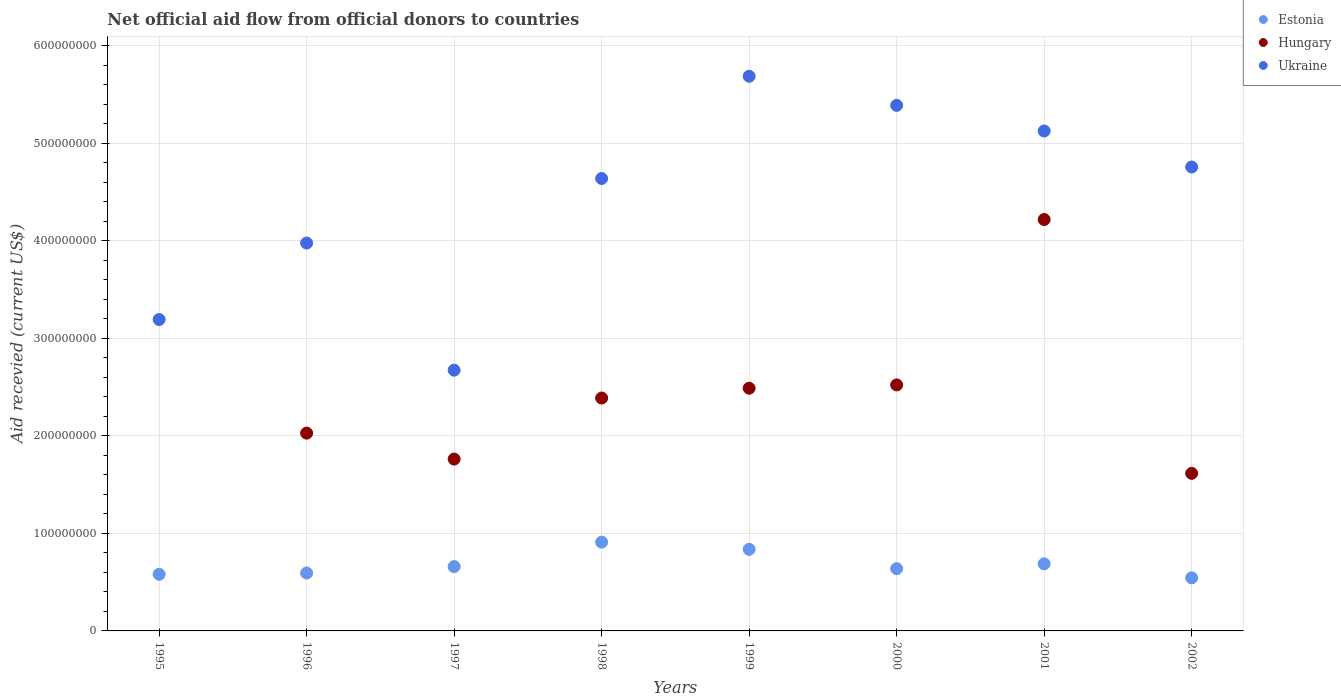How many different coloured dotlines are there?
Your response must be concise. 3. Is the number of dotlines equal to the number of legend labels?
Your answer should be compact. No. What is the total aid received in Hungary in 1997?
Your answer should be very brief. 1.76e+08. Across all years, what is the maximum total aid received in Ukraine?
Your response must be concise. 5.69e+08. In which year was the total aid received in Hungary maximum?
Provide a succinct answer. 2001. What is the total total aid received in Estonia in the graph?
Keep it short and to the point. 5.45e+08. What is the difference between the total aid received in Ukraine in 1996 and that in 1997?
Ensure brevity in your answer.  1.30e+08. What is the difference between the total aid received in Estonia in 2002 and the total aid received in Ukraine in 1997?
Offer a very short reply. -2.13e+08. What is the average total aid received in Hungary per year?
Provide a short and direct response. 2.13e+08. In the year 1996, what is the difference between the total aid received in Hungary and total aid received in Estonia?
Make the answer very short. 1.43e+08. What is the ratio of the total aid received in Hungary in 1998 to that in 1999?
Offer a very short reply. 0.96. Is the difference between the total aid received in Hungary in 2000 and 2001 greater than the difference between the total aid received in Estonia in 2000 and 2001?
Ensure brevity in your answer.  No. What is the difference between the highest and the second highest total aid received in Ukraine?
Provide a short and direct response. 2.98e+07. What is the difference between the highest and the lowest total aid received in Ukraine?
Give a very brief answer. 3.01e+08. In how many years, is the total aid received in Estonia greater than the average total aid received in Estonia taken over all years?
Ensure brevity in your answer.  3. Is the sum of the total aid received in Ukraine in 1997 and 2001 greater than the maximum total aid received in Hungary across all years?
Offer a very short reply. Yes. Is it the case that in every year, the sum of the total aid received in Estonia and total aid received in Hungary  is greater than the total aid received in Ukraine?
Offer a terse response. No. Does the total aid received in Hungary monotonically increase over the years?
Keep it short and to the point. No. How many years are there in the graph?
Your answer should be compact. 8. What is the difference between two consecutive major ticks on the Y-axis?
Provide a succinct answer. 1.00e+08. Does the graph contain grids?
Provide a succinct answer. Yes. Where does the legend appear in the graph?
Make the answer very short. Top right. How many legend labels are there?
Your answer should be very brief. 3. How are the legend labels stacked?
Provide a succinct answer. Vertical. What is the title of the graph?
Keep it short and to the point. Net official aid flow from official donors to countries. What is the label or title of the Y-axis?
Offer a very short reply. Aid recevied (current US$). What is the Aid recevied (current US$) of Estonia in 1995?
Ensure brevity in your answer.  5.80e+07. What is the Aid recevied (current US$) in Hungary in 1995?
Keep it short and to the point. 0. What is the Aid recevied (current US$) of Ukraine in 1995?
Provide a short and direct response. 3.19e+08. What is the Aid recevied (current US$) of Estonia in 1996?
Keep it short and to the point. 5.94e+07. What is the Aid recevied (current US$) in Hungary in 1996?
Offer a terse response. 2.03e+08. What is the Aid recevied (current US$) in Ukraine in 1996?
Ensure brevity in your answer.  3.98e+08. What is the Aid recevied (current US$) in Estonia in 1997?
Provide a succinct answer. 6.59e+07. What is the Aid recevied (current US$) in Hungary in 1997?
Offer a terse response. 1.76e+08. What is the Aid recevied (current US$) in Ukraine in 1997?
Provide a short and direct response. 2.67e+08. What is the Aid recevied (current US$) in Estonia in 1998?
Make the answer very short. 9.10e+07. What is the Aid recevied (current US$) in Hungary in 1998?
Your answer should be very brief. 2.39e+08. What is the Aid recevied (current US$) of Ukraine in 1998?
Ensure brevity in your answer.  4.64e+08. What is the Aid recevied (current US$) of Estonia in 1999?
Provide a short and direct response. 8.36e+07. What is the Aid recevied (current US$) of Hungary in 1999?
Your response must be concise. 2.49e+08. What is the Aid recevied (current US$) of Ukraine in 1999?
Offer a terse response. 5.69e+08. What is the Aid recevied (current US$) of Estonia in 2000?
Make the answer very short. 6.38e+07. What is the Aid recevied (current US$) of Hungary in 2000?
Your response must be concise. 2.52e+08. What is the Aid recevied (current US$) of Ukraine in 2000?
Offer a terse response. 5.39e+08. What is the Aid recevied (current US$) in Estonia in 2001?
Make the answer very short. 6.88e+07. What is the Aid recevied (current US$) in Hungary in 2001?
Offer a terse response. 4.22e+08. What is the Aid recevied (current US$) in Ukraine in 2001?
Provide a succinct answer. 5.12e+08. What is the Aid recevied (current US$) in Estonia in 2002?
Your answer should be compact. 5.44e+07. What is the Aid recevied (current US$) of Hungary in 2002?
Provide a succinct answer. 1.62e+08. What is the Aid recevied (current US$) of Ukraine in 2002?
Offer a very short reply. 4.76e+08. Across all years, what is the maximum Aid recevied (current US$) in Estonia?
Provide a short and direct response. 9.10e+07. Across all years, what is the maximum Aid recevied (current US$) in Hungary?
Provide a short and direct response. 4.22e+08. Across all years, what is the maximum Aid recevied (current US$) of Ukraine?
Provide a succinct answer. 5.69e+08. Across all years, what is the minimum Aid recevied (current US$) of Estonia?
Provide a short and direct response. 5.44e+07. Across all years, what is the minimum Aid recevied (current US$) of Hungary?
Provide a short and direct response. 0. Across all years, what is the minimum Aid recevied (current US$) of Ukraine?
Ensure brevity in your answer.  2.67e+08. What is the total Aid recevied (current US$) of Estonia in the graph?
Your response must be concise. 5.45e+08. What is the total Aid recevied (current US$) of Hungary in the graph?
Offer a terse response. 1.70e+09. What is the total Aid recevied (current US$) in Ukraine in the graph?
Your answer should be very brief. 3.54e+09. What is the difference between the Aid recevied (current US$) of Estonia in 1995 and that in 1996?
Your answer should be very brief. -1.32e+06. What is the difference between the Aid recevied (current US$) in Ukraine in 1995 and that in 1996?
Keep it short and to the point. -7.84e+07. What is the difference between the Aid recevied (current US$) of Estonia in 1995 and that in 1997?
Your answer should be compact. -7.86e+06. What is the difference between the Aid recevied (current US$) in Ukraine in 1995 and that in 1997?
Ensure brevity in your answer.  5.19e+07. What is the difference between the Aid recevied (current US$) in Estonia in 1995 and that in 1998?
Ensure brevity in your answer.  -3.29e+07. What is the difference between the Aid recevied (current US$) of Ukraine in 1995 and that in 1998?
Your answer should be compact. -1.45e+08. What is the difference between the Aid recevied (current US$) in Estonia in 1995 and that in 1999?
Provide a short and direct response. -2.56e+07. What is the difference between the Aid recevied (current US$) of Ukraine in 1995 and that in 1999?
Your response must be concise. -2.49e+08. What is the difference between the Aid recevied (current US$) of Estonia in 1995 and that in 2000?
Your answer should be compact. -5.78e+06. What is the difference between the Aid recevied (current US$) of Ukraine in 1995 and that in 2000?
Provide a succinct answer. -2.20e+08. What is the difference between the Aid recevied (current US$) of Estonia in 1995 and that in 2001?
Ensure brevity in your answer.  -1.07e+07. What is the difference between the Aid recevied (current US$) of Ukraine in 1995 and that in 2001?
Provide a short and direct response. -1.93e+08. What is the difference between the Aid recevied (current US$) in Estonia in 1995 and that in 2002?
Make the answer very short. 3.64e+06. What is the difference between the Aid recevied (current US$) of Ukraine in 1995 and that in 2002?
Provide a succinct answer. -1.56e+08. What is the difference between the Aid recevied (current US$) of Estonia in 1996 and that in 1997?
Provide a succinct answer. -6.54e+06. What is the difference between the Aid recevied (current US$) of Hungary in 1996 and that in 1997?
Ensure brevity in your answer.  2.66e+07. What is the difference between the Aid recevied (current US$) in Ukraine in 1996 and that in 1997?
Your answer should be very brief. 1.30e+08. What is the difference between the Aid recevied (current US$) of Estonia in 1996 and that in 1998?
Make the answer very short. -3.16e+07. What is the difference between the Aid recevied (current US$) of Hungary in 1996 and that in 1998?
Make the answer very short. -3.60e+07. What is the difference between the Aid recevied (current US$) of Ukraine in 1996 and that in 1998?
Your answer should be very brief. -6.61e+07. What is the difference between the Aid recevied (current US$) in Estonia in 1996 and that in 1999?
Offer a terse response. -2.42e+07. What is the difference between the Aid recevied (current US$) in Hungary in 1996 and that in 1999?
Offer a terse response. -4.60e+07. What is the difference between the Aid recevied (current US$) of Ukraine in 1996 and that in 1999?
Give a very brief answer. -1.71e+08. What is the difference between the Aid recevied (current US$) in Estonia in 1996 and that in 2000?
Provide a short and direct response. -4.46e+06. What is the difference between the Aid recevied (current US$) in Hungary in 1996 and that in 2000?
Ensure brevity in your answer.  -4.94e+07. What is the difference between the Aid recevied (current US$) in Ukraine in 1996 and that in 2000?
Offer a terse response. -1.41e+08. What is the difference between the Aid recevied (current US$) of Estonia in 1996 and that in 2001?
Keep it short and to the point. -9.41e+06. What is the difference between the Aid recevied (current US$) in Hungary in 1996 and that in 2001?
Offer a terse response. -2.19e+08. What is the difference between the Aid recevied (current US$) in Ukraine in 1996 and that in 2001?
Give a very brief answer. -1.15e+08. What is the difference between the Aid recevied (current US$) in Estonia in 1996 and that in 2002?
Make the answer very short. 4.96e+06. What is the difference between the Aid recevied (current US$) in Hungary in 1996 and that in 2002?
Keep it short and to the point. 4.12e+07. What is the difference between the Aid recevied (current US$) in Ukraine in 1996 and that in 2002?
Keep it short and to the point. -7.79e+07. What is the difference between the Aid recevied (current US$) in Estonia in 1997 and that in 1998?
Make the answer very short. -2.51e+07. What is the difference between the Aid recevied (current US$) of Hungary in 1997 and that in 1998?
Your answer should be compact. -6.26e+07. What is the difference between the Aid recevied (current US$) in Ukraine in 1997 and that in 1998?
Ensure brevity in your answer.  -1.96e+08. What is the difference between the Aid recevied (current US$) of Estonia in 1997 and that in 1999?
Give a very brief answer. -1.77e+07. What is the difference between the Aid recevied (current US$) of Hungary in 1997 and that in 1999?
Your answer should be compact. -7.26e+07. What is the difference between the Aid recevied (current US$) of Ukraine in 1997 and that in 1999?
Provide a succinct answer. -3.01e+08. What is the difference between the Aid recevied (current US$) in Estonia in 1997 and that in 2000?
Offer a terse response. 2.08e+06. What is the difference between the Aid recevied (current US$) in Hungary in 1997 and that in 2000?
Your response must be concise. -7.60e+07. What is the difference between the Aid recevied (current US$) of Ukraine in 1997 and that in 2000?
Ensure brevity in your answer.  -2.71e+08. What is the difference between the Aid recevied (current US$) in Estonia in 1997 and that in 2001?
Provide a short and direct response. -2.87e+06. What is the difference between the Aid recevied (current US$) of Hungary in 1997 and that in 2001?
Your answer should be compact. -2.46e+08. What is the difference between the Aid recevied (current US$) in Ukraine in 1997 and that in 2001?
Your response must be concise. -2.45e+08. What is the difference between the Aid recevied (current US$) of Estonia in 1997 and that in 2002?
Make the answer very short. 1.15e+07. What is the difference between the Aid recevied (current US$) of Hungary in 1997 and that in 2002?
Your answer should be very brief. 1.46e+07. What is the difference between the Aid recevied (current US$) of Ukraine in 1997 and that in 2002?
Keep it short and to the point. -2.08e+08. What is the difference between the Aid recevied (current US$) in Estonia in 1998 and that in 1999?
Your answer should be very brief. 7.37e+06. What is the difference between the Aid recevied (current US$) in Hungary in 1998 and that in 1999?
Your answer should be very brief. -1.00e+07. What is the difference between the Aid recevied (current US$) of Ukraine in 1998 and that in 1999?
Give a very brief answer. -1.05e+08. What is the difference between the Aid recevied (current US$) in Estonia in 1998 and that in 2000?
Give a very brief answer. 2.72e+07. What is the difference between the Aid recevied (current US$) of Hungary in 1998 and that in 2000?
Offer a terse response. -1.34e+07. What is the difference between the Aid recevied (current US$) in Ukraine in 1998 and that in 2000?
Make the answer very short. -7.50e+07. What is the difference between the Aid recevied (current US$) of Estonia in 1998 and that in 2001?
Your answer should be compact. 2.22e+07. What is the difference between the Aid recevied (current US$) of Hungary in 1998 and that in 2001?
Your answer should be compact. -1.83e+08. What is the difference between the Aid recevied (current US$) of Ukraine in 1998 and that in 2001?
Offer a very short reply. -4.87e+07. What is the difference between the Aid recevied (current US$) of Estonia in 1998 and that in 2002?
Your response must be concise. 3.66e+07. What is the difference between the Aid recevied (current US$) of Hungary in 1998 and that in 2002?
Offer a very short reply. 7.72e+07. What is the difference between the Aid recevied (current US$) of Ukraine in 1998 and that in 2002?
Offer a terse response. -1.18e+07. What is the difference between the Aid recevied (current US$) of Estonia in 1999 and that in 2000?
Give a very brief answer. 1.98e+07. What is the difference between the Aid recevied (current US$) of Hungary in 1999 and that in 2000?
Make the answer very short. -3.39e+06. What is the difference between the Aid recevied (current US$) in Ukraine in 1999 and that in 2000?
Ensure brevity in your answer.  2.98e+07. What is the difference between the Aid recevied (current US$) in Estonia in 1999 and that in 2001?
Your response must be concise. 1.48e+07. What is the difference between the Aid recevied (current US$) of Hungary in 1999 and that in 2001?
Provide a short and direct response. -1.73e+08. What is the difference between the Aid recevied (current US$) of Ukraine in 1999 and that in 2001?
Ensure brevity in your answer.  5.61e+07. What is the difference between the Aid recevied (current US$) in Estonia in 1999 and that in 2002?
Offer a terse response. 2.92e+07. What is the difference between the Aid recevied (current US$) in Hungary in 1999 and that in 2002?
Provide a succinct answer. 8.73e+07. What is the difference between the Aid recevied (current US$) in Ukraine in 1999 and that in 2002?
Make the answer very short. 9.30e+07. What is the difference between the Aid recevied (current US$) in Estonia in 2000 and that in 2001?
Ensure brevity in your answer.  -4.95e+06. What is the difference between the Aid recevied (current US$) of Hungary in 2000 and that in 2001?
Your answer should be compact. -1.70e+08. What is the difference between the Aid recevied (current US$) in Ukraine in 2000 and that in 2001?
Provide a short and direct response. 2.62e+07. What is the difference between the Aid recevied (current US$) of Estonia in 2000 and that in 2002?
Offer a very short reply. 9.42e+06. What is the difference between the Aid recevied (current US$) in Hungary in 2000 and that in 2002?
Provide a short and direct response. 9.06e+07. What is the difference between the Aid recevied (current US$) in Ukraine in 2000 and that in 2002?
Provide a succinct answer. 6.32e+07. What is the difference between the Aid recevied (current US$) of Estonia in 2001 and that in 2002?
Give a very brief answer. 1.44e+07. What is the difference between the Aid recevied (current US$) in Hungary in 2001 and that in 2002?
Provide a succinct answer. 2.60e+08. What is the difference between the Aid recevied (current US$) of Ukraine in 2001 and that in 2002?
Offer a very short reply. 3.69e+07. What is the difference between the Aid recevied (current US$) of Estonia in 1995 and the Aid recevied (current US$) of Hungary in 1996?
Ensure brevity in your answer.  -1.45e+08. What is the difference between the Aid recevied (current US$) in Estonia in 1995 and the Aid recevied (current US$) in Ukraine in 1996?
Make the answer very short. -3.40e+08. What is the difference between the Aid recevied (current US$) of Estonia in 1995 and the Aid recevied (current US$) of Hungary in 1997?
Ensure brevity in your answer.  -1.18e+08. What is the difference between the Aid recevied (current US$) of Estonia in 1995 and the Aid recevied (current US$) of Ukraine in 1997?
Keep it short and to the point. -2.09e+08. What is the difference between the Aid recevied (current US$) of Estonia in 1995 and the Aid recevied (current US$) of Hungary in 1998?
Your answer should be compact. -1.81e+08. What is the difference between the Aid recevied (current US$) in Estonia in 1995 and the Aid recevied (current US$) in Ukraine in 1998?
Provide a short and direct response. -4.06e+08. What is the difference between the Aid recevied (current US$) of Estonia in 1995 and the Aid recevied (current US$) of Hungary in 1999?
Offer a very short reply. -1.91e+08. What is the difference between the Aid recevied (current US$) in Estonia in 1995 and the Aid recevied (current US$) in Ukraine in 1999?
Keep it short and to the point. -5.11e+08. What is the difference between the Aid recevied (current US$) of Estonia in 1995 and the Aid recevied (current US$) of Hungary in 2000?
Provide a succinct answer. -1.94e+08. What is the difference between the Aid recevied (current US$) in Estonia in 1995 and the Aid recevied (current US$) in Ukraine in 2000?
Ensure brevity in your answer.  -4.81e+08. What is the difference between the Aid recevied (current US$) of Estonia in 1995 and the Aid recevied (current US$) of Hungary in 2001?
Provide a short and direct response. -3.64e+08. What is the difference between the Aid recevied (current US$) of Estonia in 1995 and the Aid recevied (current US$) of Ukraine in 2001?
Offer a very short reply. -4.54e+08. What is the difference between the Aid recevied (current US$) in Estonia in 1995 and the Aid recevied (current US$) in Hungary in 2002?
Offer a very short reply. -1.03e+08. What is the difference between the Aid recevied (current US$) of Estonia in 1995 and the Aid recevied (current US$) of Ukraine in 2002?
Your answer should be very brief. -4.18e+08. What is the difference between the Aid recevied (current US$) in Estonia in 1996 and the Aid recevied (current US$) in Hungary in 1997?
Provide a succinct answer. -1.17e+08. What is the difference between the Aid recevied (current US$) of Estonia in 1996 and the Aid recevied (current US$) of Ukraine in 1997?
Offer a very short reply. -2.08e+08. What is the difference between the Aid recevied (current US$) of Hungary in 1996 and the Aid recevied (current US$) of Ukraine in 1997?
Your answer should be compact. -6.45e+07. What is the difference between the Aid recevied (current US$) of Estonia in 1996 and the Aid recevied (current US$) of Hungary in 1998?
Your answer should be very brief. -1.79e+08. What is the difference between the Aid recevied (current US$) in Estonia in 1996 and the Aid recevied (current US$) in Ukraine in 1998?
Provide a succinct answer. -4.04e+08. What is the difference between the Aid recevied (current US$) of Hungary in 1996 and the Aid recevied (current US$) of Ukraine in 1998?
Your answer should be very brief. -2.61e+08. What is the difference between the Aid recevied (current US$) of Estonia in 1996 and the Aid recevied (current US$) of Hungary in 1999?
Provide a short and direct response. -1.89e+08. What is the difference between the Aid recevied (current US$) of Estonia in 1996 and the Aid recevied (current US$) of Ukraine in 1999?
Offer a very short reply. -5.09e+08. What is the difference between the Aid recevied (current US$) of Hungary in 1996 and the Aid recevied (current US$) of Ukraine in 1999?
Keep it short and to the point. -3.66e+08. What is the difference between the Aid recevied (current US$) of Estonia in 1996 and the Aid recevied (current US$) of Hungary in 2000?
Offer a very short reply. -1.93e+08. What is the difference between the Aid recevied (current US$) of Estonia in 1996 and the Aid recevied (current US$) of Ukraine in 2000?
Your response must be concise. -4.79e+08. What is the difference between the Aid recevied (current US$) of Hungary in 1996 and the Aid recevied (current US$) of Ukraine in 2000?
Make the answer very short. -3.36e+08. What is the difference between the Aid recevied (current US$) of Estonia in 1996 and the Aid recevied (current US$) of Hungary in 2001?
Your response must be concise. -3.62e+08. What is the difference between the Aid recevied (current US$) in Estonia in 1996 and the Aid recevied (current US$) in Ukraine in 2001?
Provide a succinct answer. -4.53e+08. What is the difference between the Aid recevied (current US$) in Hungary in 1996 and the Aid recevied (current US$) in Ukraine in 2001?
Make the answer very short. -3.10e+08. What is the difference between the Aid recevied (current US$) of Estonia in 1996 and the Aid recevied (current US$) of Hungary in 2002?
Offer a very short reply. -1.02e+08. What is the difference between the Aid recevied (current US$) in Estonia in 1996 and the Aid recevied (current US$) in Ukraine in 2002?
Give a very brief answer. -4.16e+08. What is the difference between the Aid recevied (current US$) of Hungary in 1996 and the Aid recevied (current US$) of Ukraine in 2002?
Ensure brevity in your answer.  -2.73e+08. What is the difference between the Aid recevied (current US$) in Estonia in 1997 and the Aid recevied (current US$) in Hungary in 1998?
Your response must be concise. -1.73e+08. What is the difference between the Aid recevied (current US$) of Estonia in 1997 and the Aid recevied (current US$) of Ukraine in 1998?
Your response must be concise. -3.98e+08. What is the difference between the Aid recevied (current US$) of Hungary in 1997 and the Aid recevied (current US$) of Ukraine in 1998?
Offer a terse response. -2.88e+08. What is the difference between the Aid recevied (current US$) in Estonia in 1997 and the Aid recevied (current US$) in Hungary in 1999?
Provide a succinct answer. -1.83e+08. What is the difference between the Aid recevied (current US$) in Estonia in 1997 and the Aid recevied (current US$) in Ukraine in 1999?
Offer a terse response. -5.03e+08. What is the difference between the Aid recevied (current US$) in Hungary in 1997 and the Aid recevied (current US$) in Ukraine in 1999?
Provide a succinct answer. -3.92e+08. What is the difference between the Aid recevied (current US$) of Estonia in 1997 and the Aid recevied (current US$) of Hungary in 2000?
Make the answer very short. -1.86e+08. What is the difference between the Aid recevied (current US$) of Estonia in 1997 and the Aid recevied (current US$) of Ukraine in 2000?
Your answer should be compact. -4.73e+08. What is the difference between the Aid recevied (current US$) of Hungary in 1997 and the Aid recevied (current US$) of Ukraine in 2000?
Keep it short and to the point. -3.63e+08. What is the difference between the Aid recevied (current US$) in Estonia in 1997 and the Aid recevied (current US$) in Hungary in 2001?
Your answer should be very brief. -3.56e+08. What is the difference between the Aid recevied (current US$) of Estonia in 1997 and the Aid recevied (current US$) of Ukraine in 2001?
Keep it short and to the point. -4.47e+08. What is the difference between the Aid recevied (current US$) of Hungary in 1997 and the Aid recevied (current US$) of Ukraine in 2001?
Provide a short and direct response. -3.36e+08. What is the difference between the Aid recevied (current US$) in Estonia in 1997 and the Aid recevied (current US$) in Hungary in 2002?
Give a very brief answer. -9.56e+07. What is the difference between the Aid recevied (current US$) in Estonia in 1997 and the Aid recevied (current US$) in Ukraine in 2002?
Your answer should be very brief. -4.10e+08. What is the difference between the Aid recevied (current US$) of Hungary in 1997 and the Aid recevied (current US$) of Ukraine in 2002?
Ensure brevity in your answer.  -2.99e+08. What is the difference between the Aid recevied (current US$) of Estonia in 1998 and the Aid recevied (current US$) of Hungary in 1999?
Your response must be concise. -1.58e+08. What is the difference between the Aid recevied (current US$) of Estonia in 1998 and the Aid recevied (current US$) of Ukraine in 1999?
Your answer should be very brief. -4.78e+08. What is the difference between the Aid recevied (current US$) of Hungary in 1998 and the Aid recevied (current US$) of Ukraine in 1999?
Offer a terse response. -3.30e+08. What is the difference between the Aid recevied (current US$) in Estonia in 1998 and the Aid recevied (current US$) in Hungary in 2000?
Your response must be concise. -1.61e+08. What is the difference between the Aid recevied (current US$) in Estonia in 1998 and the Aid recevied (current US$) in Ukraine in 2000?
Ensure brevity in your answer.  -4.48e+08. What is the difference between the Aid recevied (current US$) of Hungary in 1998 and the Aid recevied (current US$) of Ukraine in 2000?
Your answer should be compact. -3.00e+08. What is the difference between the Aid recevied (current US$) in Estonia in 1998 and the Aid recevied (current US$) in Hungary in 2001?
Your answer should be very brief. -3.31e+08. What is the difference between the Aid recevied (current US$) in Estonia in 1998 and the Aid recevied (current US$) in Ukraine in 2001?
Make the answer very short. -4.21e+08. What is the difference between the Aid recevied (current US$) in Hungary in 1998 and the Aid recevied (current US$) in Ukraine in 2001?
Make the answer very short. -2.74e+08. What is the difference between the Aid recevied (current US$) in Estonia in 1998 and the Aid recevied (current US$) in Hungary in 2002?
Offer a terse response. -7.05e+07. What is the difference between the Aid recevied (current US$) of Estonia in 1998 and the Aid recevied (current US$) of Ukraine in 2002?
Provide a short and direct response. -3.85e+08. What is the difference between the Aid recevied (current US$) of Hungary in 1998 and the Aid recevied (current US$) of Ukraine in 2002?
Make the answer very short. -2.37e+08. What is the difference between the Aid recevied (current US$) in Estonia in 1999 and the Aid recevied (current US$) in Hungary in 2000?
Provide a short and direct response. -1.69e+08. What is the difference between the Aid recevied (current US$) of Estonia in 1999 and the Aid recevied (current US$) of Ukraine in 2000?
Offer a terse response. -4.55e+08. What is the difference between the Aid recevied (current US$) of Hungary in 1999 and the Aid recevied (current US$) of Ukraine in 2000?
Keep it short and to the point. -2.90e+08. What is the difference between the Aid recevied (current US$) of Estonia in 1999 and the Aid recevied (current US$) of Hungary in 2001?
Your answer should be compact. -3.38e+08. What is the difference between the Aid recevied (current US$) of Estonia in 1999 and the Aid recevied (current US$) of Ukraine in 2001?
Make the answer very short. -4.29e+08. What is the difference between the Aid recevied (current US$) in Hungary in 1999 and the Aid recevied (current US$) in Ukraine in 2001?
Your answer should be very brief. -2.64e+08. What is the difference between the Aid recevied (current US$) of Estonia in 1999 and the Aid recevied (current US$) of Hungary in 2002?
Provide a succinct answer. -7.79e+07. What is the difference between the Aid recevied (current US$) in Estonia in 1999 and the Aid recevied (current US$) in Ukraine in 2002?
Keep it short and to the point. -3.92e+08. What is the difference between the Aid recevied (current US$) in Hungary in 1999 and the Aid recevied (current US$) in Ukraine in 2002?
Ensure brevity in your answer.  -2.27e+08. What is the difference between the Aid recevied (current US$) of Estonia in 2000 and the Aid recevied (current US$) of Hungary in 2001?
Keep it short and to the point. -3.58e+08. What is the difference between the Aid recevied (current US$) in Estonia in 2000 and the Aid recevied (current US$) in Ukraine in 2001?
Your response must be concise. -4.49e+08. What is the difference between the Aid recevied (current US$) of Hungary in 2000 and the Aid recevied (current US$) of Ukraine in 2001?
Make the answer very short. -2.60e+08. What is the difference between the Aid recevied (current US$) of Estonia in 2000 and the Aid recevied (current US$) of Hungary in 2002?
Offer a terse response. -9.77e+07. What is the difference between the Aid recevied (current US$) in Estonia in 2000 and the Aid recevied (current US$) in Ukraine in 2002?
Ensure brevity in your answer.  -4.12e+08. What is the difference between the Aid recevied (current US$) in Hungary in 2000 and the Aid recevied (current US$) in Ukraine in 2002?
Your answer should be compact. -2.23e+08. What is the difference between the Aid recevied (current US$) in Estonia in 2001 and the Aid recevied (current US$) in Hungary in 2002?
Your answer should be very brief. -9.27e+07. What is the difference between the Aid recevied (current US$) in Estonia in 2001 and the Aid recevied (current US$) in Ukraine in 2002?
Provide a short and direct response. -4.07e+08. What is the difference between the Aid recevied (current US$) of Hungary in 2001 and the Aid recevied (current US$) of Ukraine in 2002?
Your answer should be very brief. -5.39e+07. What is the average Aid recevied (current US$) in Estonia per year?
Your answer should be compact. 6.81e+07. What is the average Aid recevied (current US$) of Hungary per year?
Offer a very short reply. 2.13e+08. What is the average Aid recevied (current US$) of Ukraine per year?
Make the answer very short. 4.43e+08. In the year 1995, what is the difference between the Aid recevied (current US$) in Estonia and Aid recevied (current US$) in Ukraine?
Give a very brief answer. -2.61e+08. In the year 1996, what is the difference between the Aid recevied (current US$) of Estonia and Aid recevied (current US$) of Hungary?
Your response must be concise. -1.43e+08. In the year 1996, what is the difference between the Aid recevied (current US$) in Estonia and Aid recevied (current US$) in Ukraine?
Offer a terse response. -3.38e+08. In the year 1996, what is the difference between the Aid recevied (current US$) of Hungary and Aid recevied (current US$) of Ukraine?
Make the answer very short. -1.95e+08. In the year 1997, what is the difference between the Aid recevied (current US$) in Estonia and Aid recevied (current US$) in Hungary?
Give a very brief answer. -1.10e+08. In the year 1997, what is the difference between the Aid recevied (current US$) of Estonia and Aid recevied (current US$) of Ukraine?
Offer a very short reply. -2.01e+08. In the year 1997, what is the difference between the Aid recevied (current US$) of Hungary and Aid recevied (current US$) of Ukraine?
Offer a very short reply. -9.11e+07. In the year 1998, what is the difference between the Aid recevied (current US$) in Estonia and Aid recevied (current US$) in Hungary?
Provide a short and direct response. -1.48e+08. In the year 1998, what is the difference between the Aid recevied (current US$) in Estonia and Aid recevied (current US$) in Ukraine?
Offer a very short reply. -3.73e+08. In the year 1998, what is the difference between the Aid recevied (current US$) of Hungary and Aid recevied (current US$) of Ukraine?
Offer a very short reply. -2.25e+08. In the year 1999, what is the difference between the Aid recevied (current US$) in Estonia and Aid recevied (current US$) in Hungary?
Make the answer very short. -1.65e+08. In the year 1999, what is the difference between the Aid recevied (current US$) of Estonia and Aid recevied (current US$) of Ukraine?
Provide a succinct answer. -4.85e+08. In the year 1999, what is the difference between the Aid recevied (current US$) in Hungary and Aid recevied (current US$) in Ukraine?
Provide a short and direct response. -3.20e+08. In the year 2000, what is the difference between the Aid recevied (current US$) of Estonia and Aid recevied (current US$) of Hungary?
Provide a succinct answer. -1.88e+08. In the year 2000, what is the difference between the Aid recevied (current US$) in Estonia and Aid recevied (current US$) in Ukraine?
Make the answer very short. -4.75e+08. In the year 2000, what is the difference between the Aid recevied (current US$) in Hungary and Aid recevied (current US$) in Ukraine?
Offer a terse response. -2.87e+08. In the year 2001, what is the difference between the Aid recevied (current US$) of Estonia and Aid recevied (current US$) of Hungary?
Offer a terse response. -3.53e+08. In the year 2001, what is the difference between the Aid recevied (current US$) of Estonia and Aid recevied (current US$) of Ukraine?
Offer a terse response. -4.44e+08. In the year 2001, what is the difference between the Aid recevied (current US$) in Hungary and Aid recevied (current US$) in Ukraine?
Keep it short and to the point. -9.08e+07. In the year 2002, what is the difference between the Aid recevied (current US$) in Estonia and Aid recevied (current US$) in Hungary?
Your response must be concise. -1.07e+08. In the year 2002, what is the difference between the Aid recevied (current US$) of Estonia and Aid recevied (current US$) of Ukraine?
Make the answer very short. -4.21e+08. In the year 2002, what is the difference between the Aid recevied (current US$) in Hungary and Aid recevied (current US$) in Ukraine?
Your answer should be compact. -3.14e+08. What is the ratio of the Aid recevied (current US$) in Estonia in 1995 to that in 1996?
Provide a short and direct response. 0.98. What is the ratio of the Aid recevied (current US$) of Ukraine in 1995 to that in 1996?
Make the answer very short. 0.8. What is the ratio of the Aid recevied (current US$) in Estonia in 1995 to that in 1997?
Offer a very short reply. 0.88. What is the ratio of the Aid recevied (current US$) of Ukraine in 1995 to that in 1997?
Give a very brief answer. 1.19. What is the ratio of the Aid recevied (current US$) in Estonia in 1995 to that in 1998?
Keep it short and to the point. 0.64. What is the ratio of the Aid recevied (current US$) in Ukraine in 1995 to that in 1998?
Give a very brief answer. 0.69. What is the ratio of the Aid recevied (current US$) in Estonia in 1995 to that in 1999?
Provide a short and direct response. 0.69. What is the ratio of the Aid recevied (current US$) of Ukraine in 1995 to that in 1999?
Offer a very short reply. 0.56. What is the ratio of the Aid recevied (current US$) of Estonia in 1995 to that in 2000?
Ensure brevity in your answer.  0.91. What is the ratio of the Aid recevied (current US$) in Ukraine in 1995 to that in 2000?
Your answer should be compact. 0.59. What is the ratio of the Aid recevied (current US$) of Estonia in 1995 to that in 2001?
Your answer should be very brief. 0.84. What is the ratio of the Aid recevied (current US$) in Ukraine in 1995 to that in 2001?
Ensure brevity in your answer.  0.62. What is the ratio of the Aid recevied (current US$) in Estonia in 1995 to that in 2002?
Provide a succinct answer. 1.07. What is the ratio of the Aid recevied (current US$) of Ukraine in 1995 to that in 2002?
Your answer should be very brief. 0.67. What is the ratio of the Aid recevied (current US$) in Estonia in 1996 to that in 1997?
Offer a terse response. 0.9. What is the ratio of the Aid recevied (current US$) of Hungary in 1996 to that in 1997?
Ensure brevity in your answer.  1.15. What is the ratio of the Aid recevied (current US$) in Ukraine in 1996 to that in 1997?
Offer a very short reply. 1.49. What is the ratio of the Aid recevied (current US$) in Estonia in 1996 to that in 1998?
Make the answer very short. 0.65. What is the ratio of the Aid recevied (current US$) in Hungary in 1996 to that in 1998?
Offer a terse response. 0.85. What is the ratio of the Aid recevied (current US$) in Ukraine in 1996 to that in 1998?
Your response must be concise. 0.86. What is the ratio of the Aid recevied (current US$) of Estonia in 1996 to that in 1999?
Your response must be concise. 0.71. What is the ratio of the Aid recevied (current US$) in Hungary in 1996 to that in 1999?
Offer a very short reply. 0.81. What is the ratio of the Aid recevied (current US$) in Ukraine in 1996 to that in 1999?
Offer a very short reply. 0.7. What is the ratio of the Aid recevied (current US$) in Estonia in 1996 to that in 2000?
Provide a succinct answer. 0.93. What is the ratio of the Aid recevied (current US$) in Hungary in 1996 to that in 2000?
Offer a terse response. 0.8. What is the ratio of the Aid recevied (current US$) of Ukraine in 1996 to that in 2000?
Provide a short and direct response. 0.74. What is the ratio of the Aid recevied (current US$) in Estonia in 1996 to that in 2001?
Provide a succinct answer. 0.86. What is the ratio of the Aid recevied (current US$) in Hungary in 1996 to that in 2001?
Provide a short and direct response. 0.48. What is the ratio of the Aid recevied (current US$) in Ukraine in 1996 to that in 2001?
Offer a very short reply. 0.78. What is the ratio of the Aid recevied (current US$) of Estonia in 1996 to that in 2002?
Keep it short and to the point. 1.09. What is the ratio of the Aid recevied (current US$) in Hungary in 1996 to that in 2002?
Your answer should be compact. 1.26. What is the ratio of the Aid recevied (current US$) of Ukraine in 1996 to that in 2002?
Your answer should be compact. 0.84. What is the ratio of the Aid recevied (current US$) in Estonia in 1997 to that in 1998?
Your response must be concise. 0.72. What is the ratio of the Aid recevied (current US$) of Hungary in 1997 to that in 1998?
Give a very brief answer. 0.74. What is the ratio of the Aid recevied (current US$) of Ukraine in 1997 to that in 1998?
Your answer should be compact. 0.58. What is the ratio of the Aid recevied (current US$) of Estonia in 1997 to that in 1999?
Offer a very short reply. 0.79. What is the ratio of the Aid recevied (current US$) of Hungary in 1997 to that in 1999?
Ensure brevity in your answer.  0.71. What is the ratio of the Aid recevied (current US$) of Ukraine in 1997 to that in 1999?
Make the answer very short. 0.47. What is the ratio of the Aid recevied (current US$) of Estonia in 1997 to that in 2000?
Your answer should be very brief. 1.03. What is the ratio of the Aid recevied (current US$) in Hungary in 1997 to that in 2000?
Provide a succinct answer. 0.7. What is the ratio of the Aid recevied (current US$) of Ukraine in 1997 to that in 2000?
Your answer should be compact. 0.5. What is the ratio of the Aid recevied (current US$) in Estonia in 1997 to that in 2001?
Ensure brevity in your answer.  0.96. What is the ratio of the Aid recevied (current US$) of Hungary in 1997 to that in 2001?
Offer a terse response. 0.42. What is the ratio of the Aid recevied (current US$) of Ukraine in 1997 to that in 2001?
Provide a succinct answer. 0.52. What is the ratio of the Aid recevied (current US$) of Estonia in 1997 to that in 2002?
Make the answer very short. 1.21. What is the ratio of the Aid recevied (current US$) of Hungary in 1997 to that in 2002?
Give a very brief answer. 1.09. What is the ratio of the Aid recevied (current US$) of Ukraine in 1997 to that in 2002?
Offer a very short reply. 0.56. What is the ratio of the Aid recevied (current US$) in Estonia in 1998 to that in 1999?
Give a very brief answer. 1.09. What is the ratio of the Aid recevied (current US$) of Hungary in 1998 to that in 1999?
Your answer should be very brief. 0.96. What is the ratio of the Aid recevied (current US$) of Ukraine in 1998 to that in 1999?
Keep it short and to the point. 0.82. What is the ratio of the Aid recevied (current US$) of Estonia in 1998 to that in 2000?
Make the answer very short. 1.43. What is the ratio of the Aid recevied (current US$) in Hungary in 1998 to that in 2000?
Your response must be concise. 0.95. What is the ratio of the Aid recevied (current US$) in Ukraine in 1998 to that in 2000?
Ensure brevity in your answer.  0.86. What is the ratio of the Aid recevied (current US$) in Estonia in 1998 to that in 2001?
Make the answer very short. 1.32. What is the ratio of the Aid recevied (current US$) in Hungary in 1998 to that in 2001?
Provide a short and direct response. 0.57. What is the ratio of the Aid recevied (current US$) of Ukraine in 1998 to that in 2001?
Offer a terse response. 0.91. What is the ratio of the Aid recevied (current US$) in Estonia in 1998 to that in 2002?
Make the answer very short. 1.67. What is the ratio of the Aid recevied (current US$) in Hungary in 1998 to that in 2002?
Your response must be concise. 1.48. What is the ratio of the Aid recevied (current US$) of Ukraine in 1998 to that in 2002?
Your response must be concise. 0.98. What is the ratio of the Aid recevied (current US$) of Estonia in 1999 to that in 2000?
Offer a terse response. 1.31. What is the ratio of the Aid recevied (current US$) in Hungary in 1999 to that in 2000?
Provide a short and direct response. 0.99. What is the ratio of the Aid recevied (current US$) in Ukraine in 1999 to that in 2000?
Your answer should be compact. 1.06. What is the ratio of the Aid recevied (current US$) of Estonia in 1999 to that in 2001?
Give a very brief answer. 1.22. What is the ratio of the Aid recevied (current US$) of Hungary in 1999 to that in 2001?
Your answer should be very brief. 0.59. What is the ratio of the Aid recevied (current US$) in Ukraine in 1999 to that in 2001?
Keep it short and to the point. 1.11. What is the ratio of the Aid recevied (current US$) of Estonia in 1999 to that in 2002?
Provide a short and direct response. 1.54. What is the ratio of the Aid recevied (current US$) in Hungary in 1999 to that in 2002?
Your answer should be compact. 1.54. What is the ratio of the Aid recevied (current US$) in Ukraine in 1999 to that in 2002?
Ensure brevity in your answer.  1.2. What is the ratio of the Aid recevied (current US$) in Estonia in 2000 to that in 2001?
Your response must be concise. 0.93. What is the ratio of the Aid recevied (current US$) of Hungary in 2000 to that in 2001?
Make the answer very short. 0.6. What is the ratio of the Aid recevied (current US$) of Ukraine in 2000 to that in 2001?
Your answer should be very brief. 1.05. What is the ratio of the Aid recevied (current US$) in Estonia in 2000 to that in 2002?
Offer a terse response. 1.17. What is the ratio of the Aid recevied (current US$) of Hungary in 2000 to that in 2002?
Ensure brevity in your answer.  1.56. What is the ratio of the Aid recevied (current US$) in Ukraine in 2000 to that in 2002?
Make the answer very short. 1.13. What is the ratio of the Aid recevied (current US$) of Estonia in 2001 to that in 2002?
Offer a terse response. 1.26. What is the ratio of the Aid recevied (current US$) of Hungary in 2001 to that in 2002?
Provide a short and direct response. 2.61. What is the ratio of the Aid recevied (current US$) of Ukraine in 2001 to that in 2002?
Give a very brief answer. 1.08. What is the difference between the highest and the second highest Aid recevied (current US$) in Estonia?
Make the answer very short. 7.37e+06. What is the difference between the highest and the second highest Aid recevied (current US$) in Hungary?
Your answer should be very brief. 1.70e+08. What is the difference between the highest and the second highest Aid recevied (current US$) in Ukraine?
Your answer should be compact. 2.98e+07. What is the difference between the highest and the lowest Aid recevied (current US$) of Estonia?
Give a very brief answer. 3.66e+07. What is the difference between the highest and the lowest Aid recevied (current US$) in Hungary?
Make the answer very short. 4.22e+08. What is the difference between the highest and the lowest Aid recevied (current US$) of Ukraine?
Ensure brevity in your answer.  3.01e+08. 